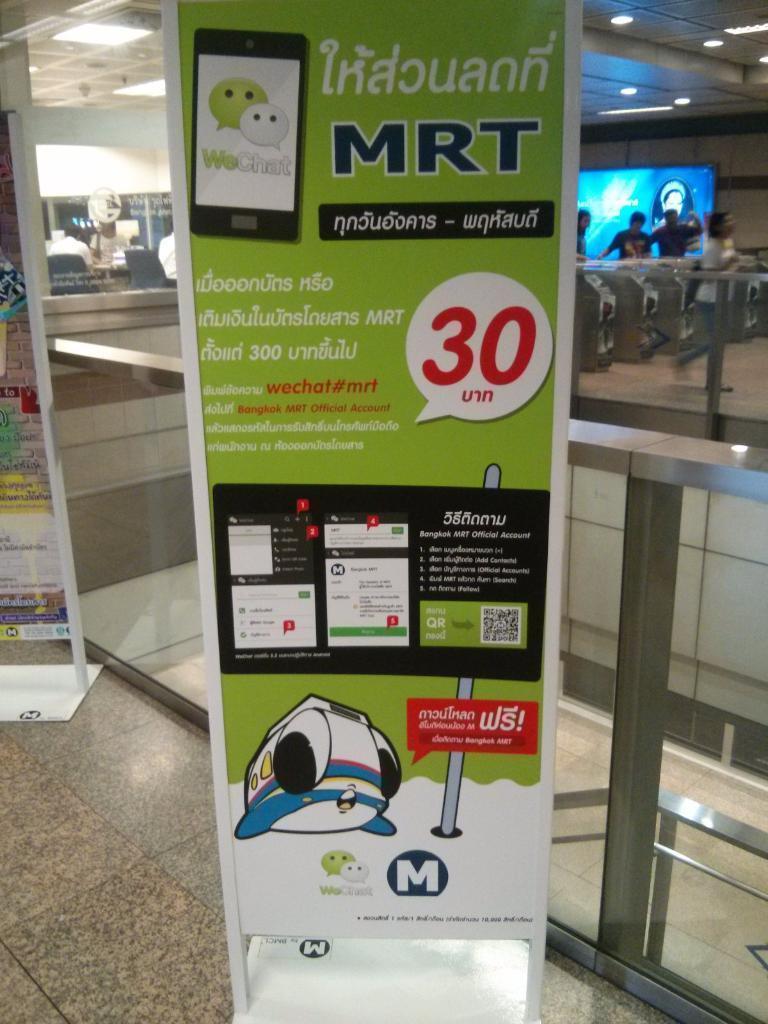In one or two sentences, can you explain what this image depicts? In this image in front there are boards. Behind them there is a glass wall. At the bottom of the image there is a floor. On the right side of the image there are people. Behind them there is a screen. On the left side of the image there are people sitting on the chairs. There is a wall. On top of the image there are lights. 